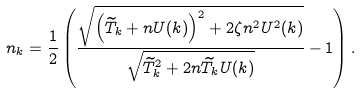<formula> <loc_0><loc_0><loc_500><loc_500>n _ { k } = \frac { 1 } { 2 } \left ( \frac { \sqrt { \left ( \widetilde { T } _ { k } + n U ( k ) \right ) ^ { 2 } + 2 \zeta n ^ { 2 } U ^ { 2 } ( k ) } } { \sqrt { \widetilde { T } _ { k } ^ { 2 } + 2 n \widetilde { T } _ { k } U ( k ) } } - 1 \right ) .</formula> 